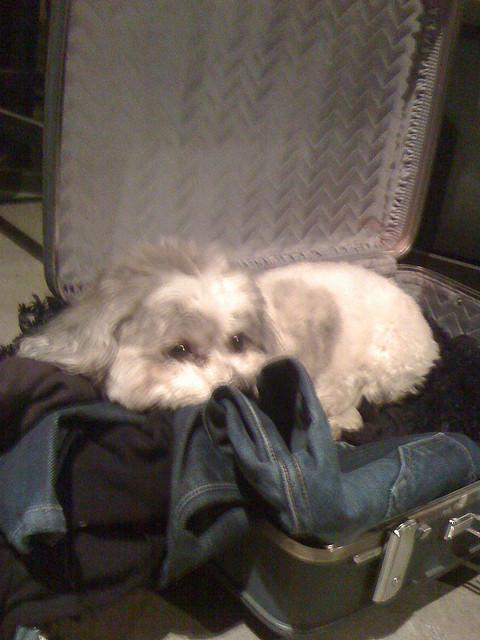How many suitcases are there?
Give a very brief answer. 2. How many dogs are in the picture?
Give a very brief answer. 1. How many people are sitting on laps?
Give a very brief answer. 0. 